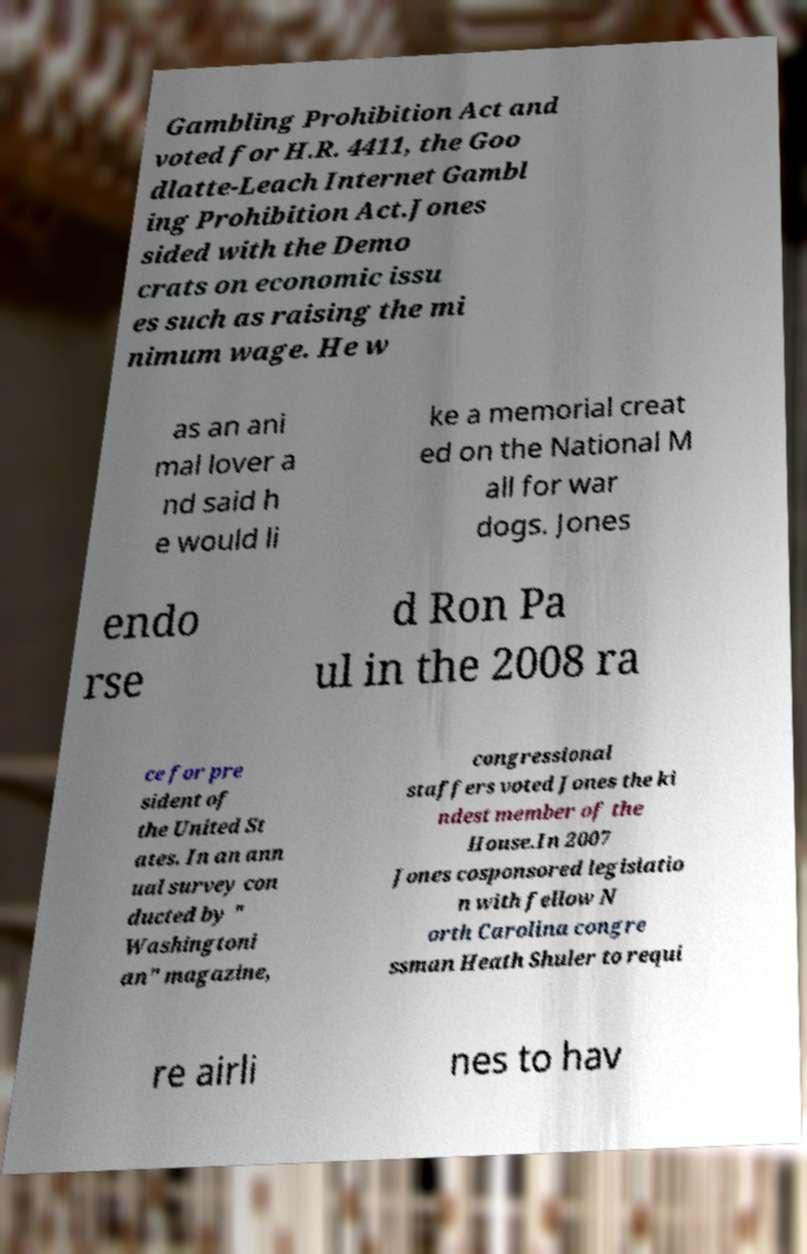Could you extract and type out the text from this image? Gambling Prohibition Act and voted for H.R. 4411, the Goo dlatte-Leach Internet Gambl ing Prohibition Act.Jones sided with the Demo crats on economic issu es such as raising the mi nimum wage. He w as an ani mal lover a nd said h e would li ke a memorial creat ed on the National M all for war dogs. Jones endo rse d Ron Pa ul in the 2008 ra ce for pre sident of the United St ates. In an ann ual survey con ducted by " Washingtoni an" magazine, congressional staffers voted Jones the ki ndest member of the House.In 2007 Jones cosponsored legislatio n with fellow N orth Carolina congre ssman Heath Shuler to requi re airli nes to hav 